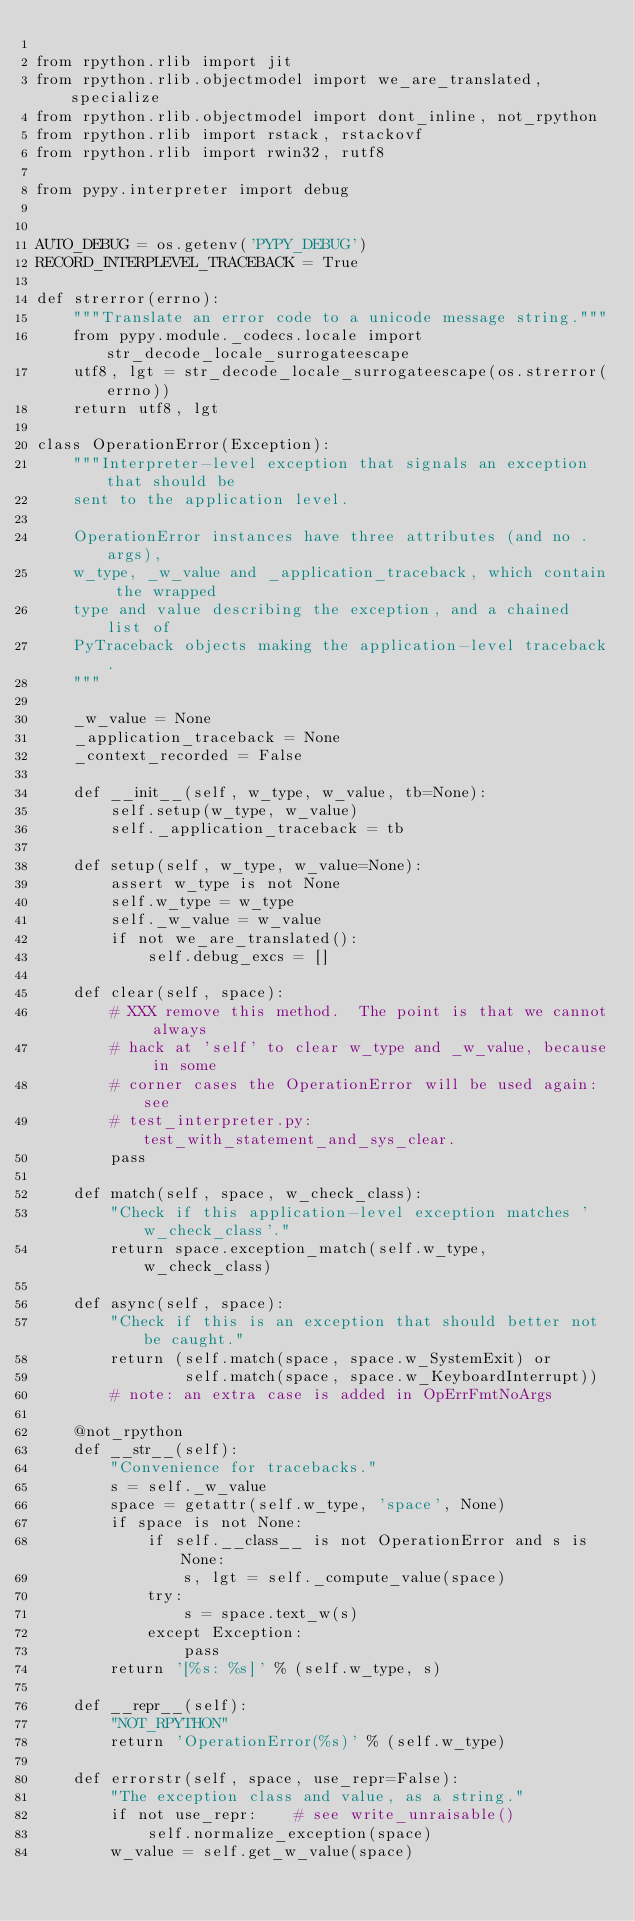Convert code to text. <code><loc_0><loc_0><loc_500><loc_500><_Python_>
from rpython.rlib import jit
from rpython.rlib.objectmodel import we_are_translated, specialize
from rpython.rlib.objectmodel import dont_inline, not_rpython
from rpython.rlib import rstack, rstackovf
from rpython.rlib import rwin32, rutf8

from pypy.interpreter import debug


AUTO_DEBUG = os.getenv('PYPY_DEBUG')
RECORD_INTERPLEVEL_TRACEBACK = True

def strerror(errno):
    """Translate an error code to a unicode message string."""
    from pypy.module._codecs.locale import str_decode_locale_surrogateescape
    utf8, lgt = str_decode_locale_surrogateescape(os.strerror(errno))
    return utf8, lgt

class OperationError(Exception):
    """Interpreter-level exception that signals an exception that should be
    sent to the application level.

    OperationError instances have three attributes (and no .args),
    w_type, _w_value and _application_traceback, which contain the wrapped
    type and value describing the exception, and a chained list of
    PyTraceback objects making the application-level traceback.
    """

    _w_value = None
    _application_traceback = None
    _context_recorded = False

    def __init__(self, w_type, w_value, tb=None):
        self.setup(w_type, w_value)
        self._application_traceback = tb

    def setup(self, w_type, w_value=None):
        assert w_type is not None
        self.w_type = w_type
        self._w_value = w_value
        if not we_are_translated():
            self.debug_excs = []

    def clear(self, space):
        # XXX remove this method.  The point is that we cannot always
        # hack at 'self' to clear w_type and _w_value, because in some
        # corner cases the OperationError will be used again: see
        # test_interpreter.py:test_with_statement_and_sys_clear.
        pass

    def match(self, space, w_check_class):
        "Check if this application-level exception matches 'w_check_class'."
        return space.exception_match(self.w_type, w_check_class)

    def async(self, space):
        "Check if this is an exception that should better not be caught."
        return (self.match(space, space.w_SystemExit) or
                self.match(space, space.w_KeyboardInterrupt))
        # note: an extra case is added in OpErrFmtNoArgs

    @not_rpython
    def __str__(self):
        "Convenience for tracebacks."
        s = self._w_value
        space = getattr(self.w_type, 'space', None)
        if space is not None:
            if self.__class__ is not OperationError and s is None:
                s, lgt = self._compute_value(space)
            try:
                s = space.text_w(s)
            except Exception:
                pass
        return '[%s: %s]' % (self.w_type, s)

    def __repr__(self):
        "NOT_RPYTHON"
        return 'OperationError(%s)' % (self.w_type)

    def errorstr(self, space, use_repr=False):
        "The exception class and value, as a string."
        if not use_repr:    # see write_unraisable()
            self.normalize_exception(space)
        w_value = self.get_w_value(space)</code> 